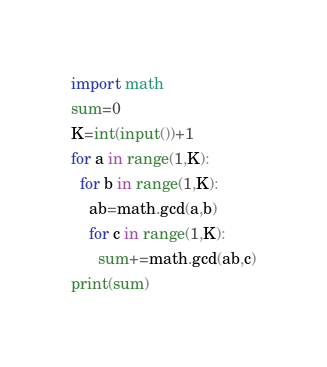<code> <loc_0><loc_0><loc_500><loc_500><_Python_>import math
sum=0
K=int(input())+1
for a in range(1,K):
  for b in range(1,K):
    ab=math.gcd(a,b)
    for c in range(1,K):
      sum+=math.gcd(ab,c)
print(sum)
</code> 